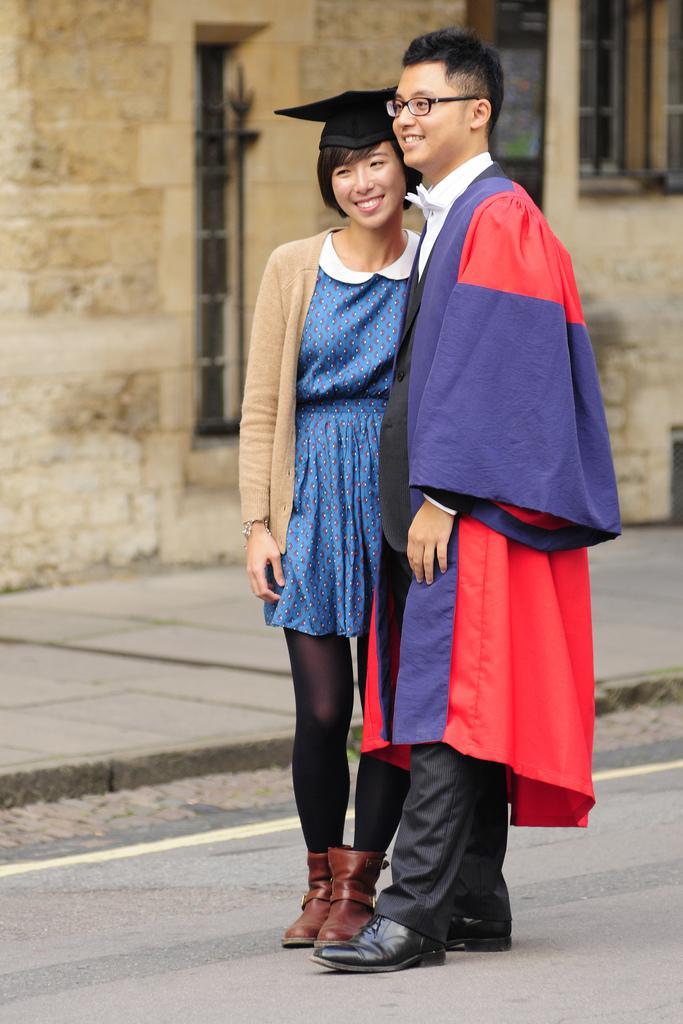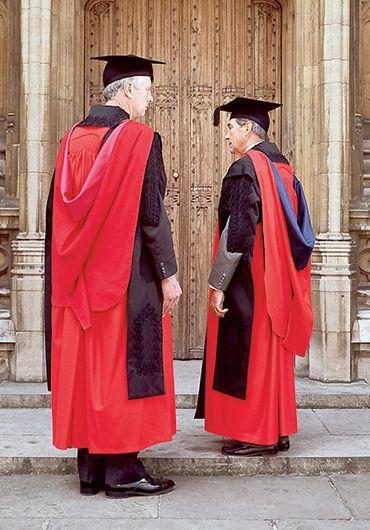The first image is the image on the left, the second image is the image on the right. Considering the images on both sides, is "An image does not show exactly two people dressed for an occasion." valid? Answer yes or no. No. 